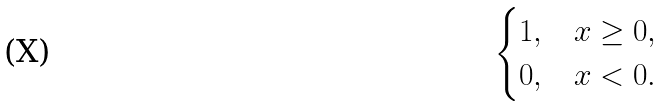Convert formula to latex. <formula><loc_0><loc_0><loc_500><loc_500>\begin{cases} 1 , & x \geq 0 , \\ 0 , & x < 0 . \end{cases}</formula> 